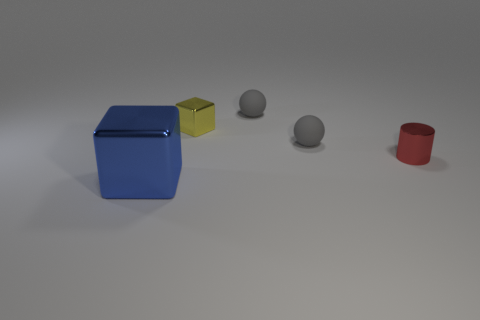How many gray balls have the same size as the yellow shiny object?
Keep it short and to the point. 2. There is a metal cube behind the blue shiny cube; is it the same size as the small red object?
Your response must be concise. Yes. The metallic object that is both in front of the yellow shiny thing and to the right of the blue cube has what shape?
Provide a succinct answer. Cylinder. There is a small red thing; are there any small balls in front of it?
Make the answer very short. No. Is there anything else that is the same shape as the large metal thing?
Give a very brief answer. Yes. Do the large metallic thing and the small yellow metallic thing have the same shape?
Ensure brevity in your answer.  Yes. Is the number of rubber balls on the left side of the red shiny thing the same as the number of metallic cylinders left of the blue block?
Ensure brevity in your answer.  No. How many large things are blue shiny cubes or blue metallic balls?
Offer a terse response. 1. Are there the same number of yellow things behind the yellow shiny object and red things?
Your answer should be very brief. No. There is a metal cube that is behind the big blue metallic thing; are there any shiny cylinders left of it?
Provide a short and direct response. No. 